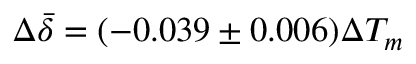<formula> <loc_0><loc_0><loc_500><loc_500>\Delta \bar { \delta } = ( - 0 . 0 3 9 \pm 0 . 0 0 6 ) \Delta T _ { m }</formula> 